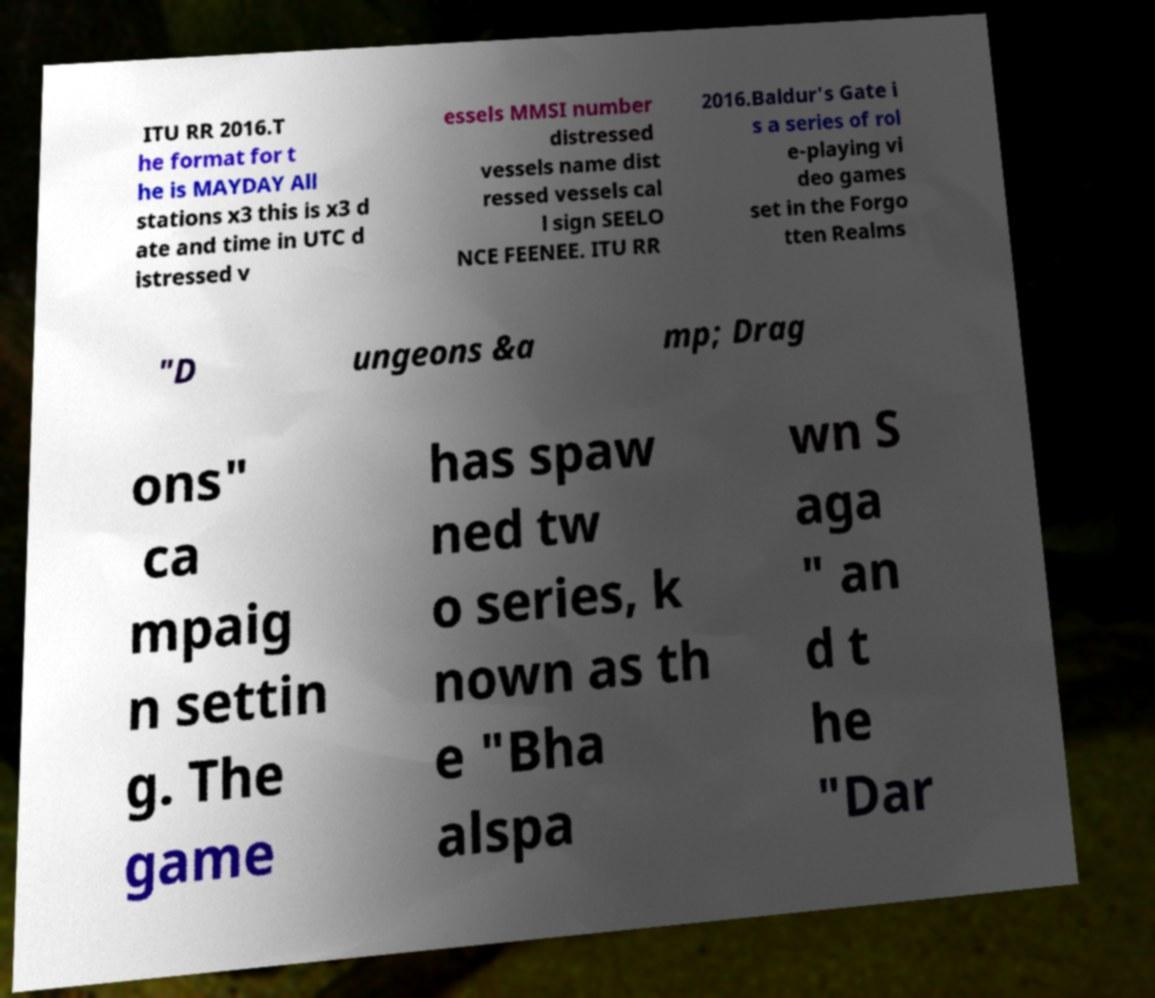I need the written content from this picture converted into text. Can you do that? ITU RR 2016.T he format for t he is MAYDAY All stations x3 this is x3 d ate and time in UTC d istressed v essels MMSI number distressed vessels name dist ressed vessels cal l sign SEELO NCE FEENEE. ITU RR 2016.Baldur's Gate i s a series of rol e-playing vi deo games set in the Forgo tten Realms "D ungeons &a mp; Drag ons" ca mpaig n settin g. The game has spaw ned tw o series, k nown as th e "Bha alspa wn S aga " an d t he "Dar 